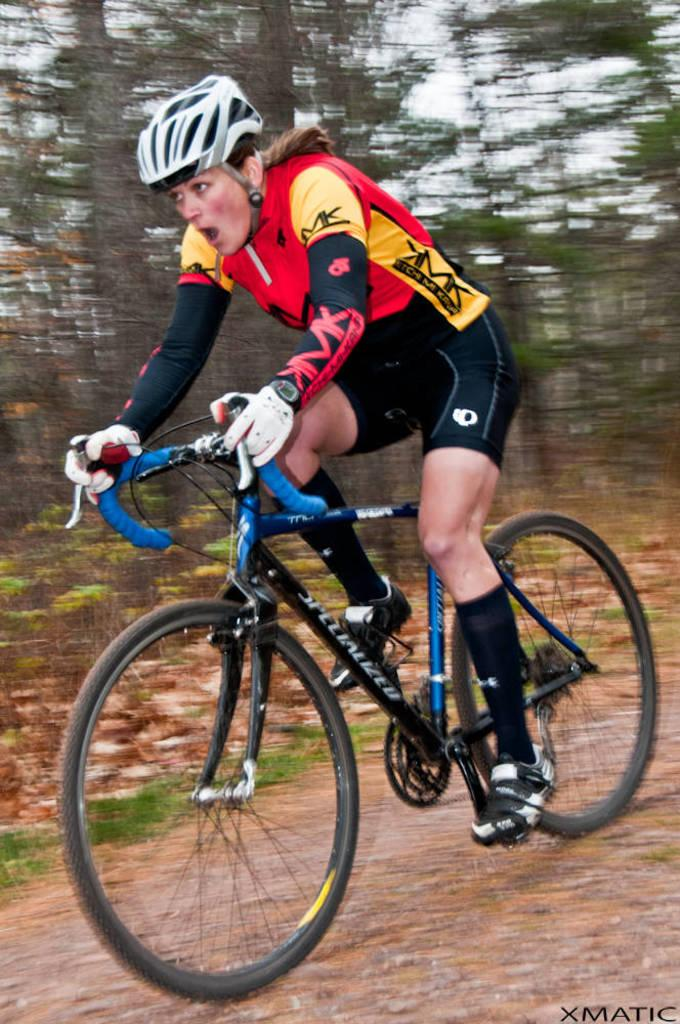Who is the main subject in the image? There is a woman in the image. What is the woman doing in the image? The woman is riding a bicycle. What safety precaution is the woman taking while riding the bicycle? The woman is wearing a helmet. What type of hook can be seen on the woman's bicycle in the image? There is no hook visible on the woman's bicycle in the image. 